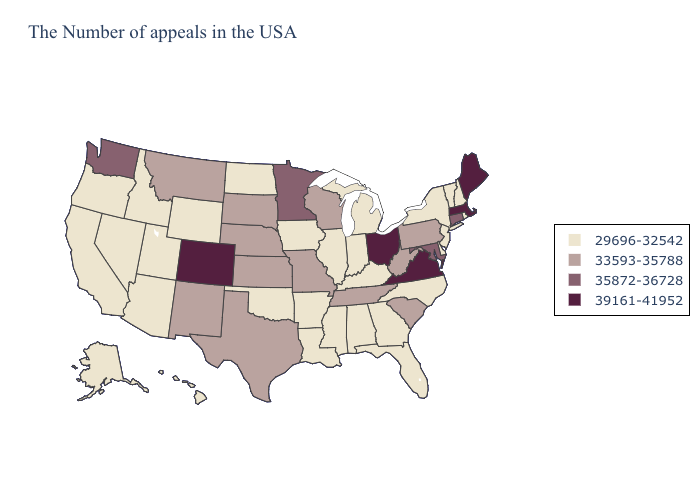What is the highest value in the MidWest ?
Answer briefly. 39161-41952. Which states have the lowest value in the USA?
Answer briefly. Rhode Island, New Hampshire, Vermont, New York, New Jersey, Delaware, North Carolina, Florida, Georgia, Michigan, Kentucky, Indiana, Alabama, Illinois, Mississippi, Louisiana, Arkansas, Iowa, Oklahoma, North Dakota, Wyoming, Utah, Arizona, Idaho, Nevada, California, Oregon, Alaska, Hawaii. Name the states that have a value in the range 33593-35788?
Give a very brief answer. Pennsylvania, South Carolina, West Virginia, Tennessee, Wisconsin, Missouri, Kansas, Nebraska, Texas, South Dakota, New Mexico, Montana. Among the states that border Minnesota , does South Dakota have the lowest value?
Write a very short answer. No. Name the states that have a value in the range 39161-41952?
Quick response, please. Maine, Massachusetts, Virginia, Ohio, Colorado. Which states have the lowest value in the USA?
Write a very short answer. Rhode Island, New Hampshire, Vermont, New York, New Jersey, Delaware, North Carolina, Florida, Georgia, Michigan, Kentucky, Indiana, Alabama, Illinois, Mississippi, Louisiana, Arkansas, Iowa, Oklahoma, North Dakota, Wyoming, Utah, Arizona, Idaho, Nevada, California, Oregon, Alaska, Hawaii. Name the states that have a value in the range 39161-41952?
Write a very short answer. Maine, Massachusetts, Virginia, Ohio, Colorado. Name the states that have a value in the range 33593-35788?
Quick response, please. Pennsylvania, South Carolina, West Virginia, Tennessee, Wisconsin, Missouri, Kansas, Nebraska, Texas, South Dakota, New Mexico, Montana. Among the states that border Virginia , which have the highest value?
Answer briefly. Maryland. Does the map have missing data?
Give a very brief answer. No. Among the states that border Ohio , does Michigan have the highest value?
Keep it brief. No. Which states hav the highest value in the Northeast?
Keep it brief. Maine, Massachusetts. How many symbols are there in the legend?
Give a very brief answer. 4. Which states have the highest value in the USA?
Write a very short answer. Maine, Massachusetts, Virginia, Ohio, Colorado. Does the first symbol in the legend represent the smallest category?
Write a very short answer. Yes. 